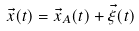Convert formula to latex. <formula><loc_0><loc_0><loc_500><loc_500>\vec { x } ( t ) = \vec { x } _ { A } ( t ) + \vec { \xi } ( t )</formula> 